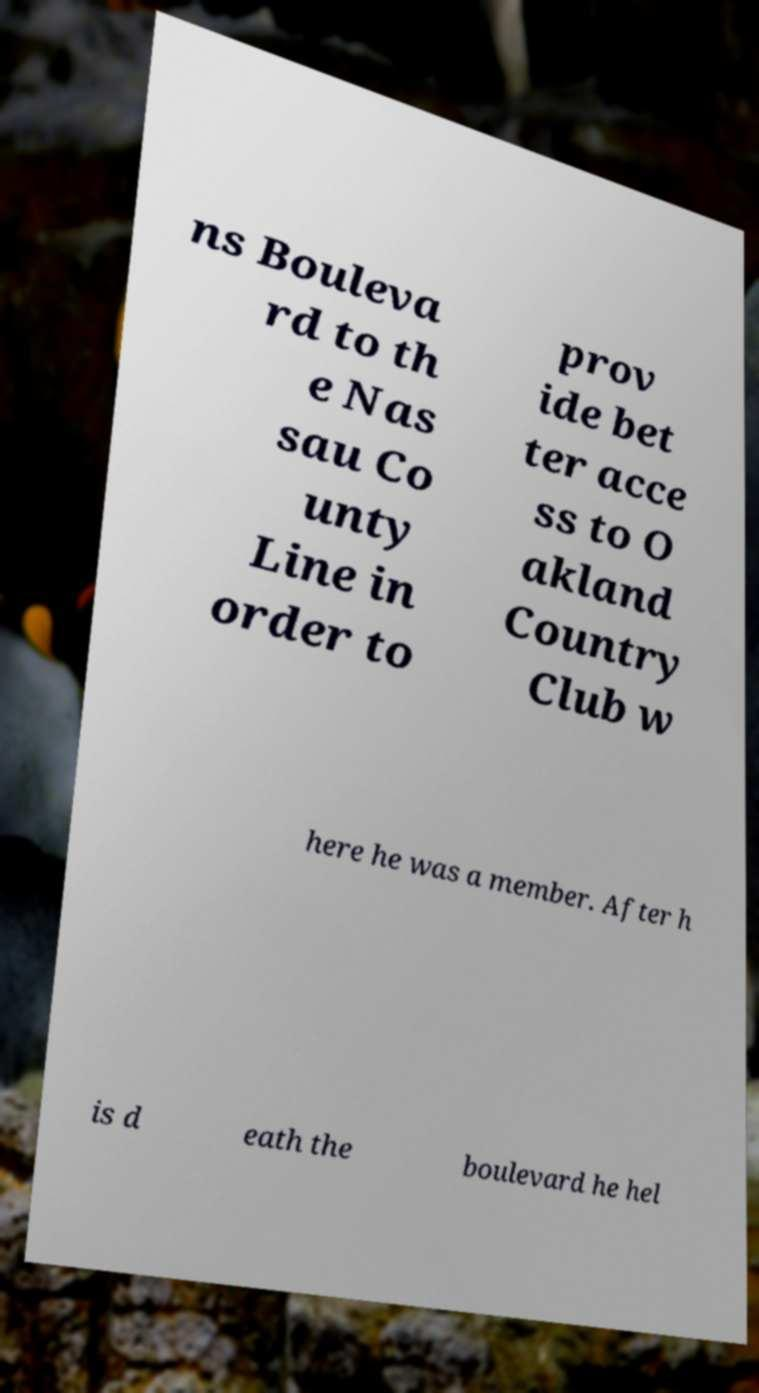Could you assist in decoding the text presented in this image and type it out clearly? ns Bouleva rd to th e Nas sau Co unty Line in order to prov ide bet ter acce ss to O akland Country Club w here he was a member. After h is d eath the boulevard he hel 